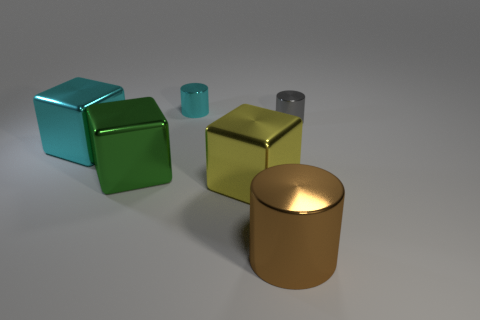Add 3 yellow things. How many objects exist? 9 Subtract all large cyan things. Subtract all tiny objects. How many objects are left? 3 Add 4 big cylinders. How many big cylinders are left? 5 Add 3 tiny red rubber things. How many tiny red rubber things exist? 3 Subtract 0 blue cylinders. How many objects are left? 6 